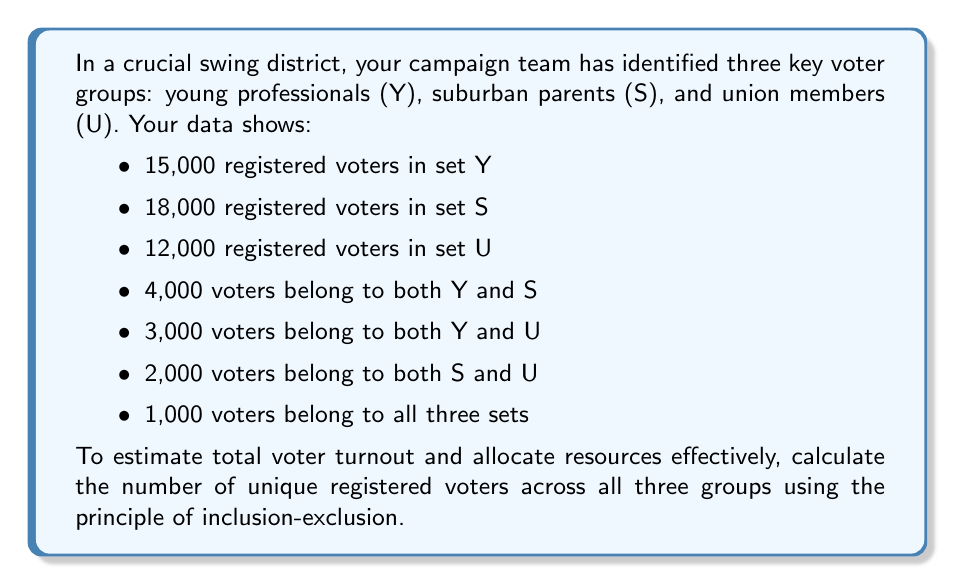Can you answer this question? To solve this problem, we'll use the principle of inclusion-exclusion for three sets. The formula is:

$$ |Y \cup S \cup U| = |Y| + |S| + |U| - |Y \cap S| - |Y \cap U| - |S \cap U| + |Y \cap S \cap U| $$

Let's plug in the values we know:

1. $|Y| = 15,000$
2. $|S| = 18,000$
3. $|U| = 12,000$
4. $|Y \cap S| = 4,000$
5. $|Y \cap U| = 3,000$
6. $|S \cap U| = 2,000$
7. $|Y \cap S \cap U| = 1,000$

Now, let's calculate:

$$ \begin{align*}
|Y \cup S \cup U| &= 15,000 + 18,000 + 12,000 - 4,000 - 3,000 - 2,000 + 1,000 \\
&= 45,000 - 9,000 + 1,000 \\
&= 37,000
\end{align*} $$

This calculation accounts for all unique voters while avoiding double-counting those who belong to multiple sets.
Answer: The total number of unique registered voters across all three groups is 37,000. 